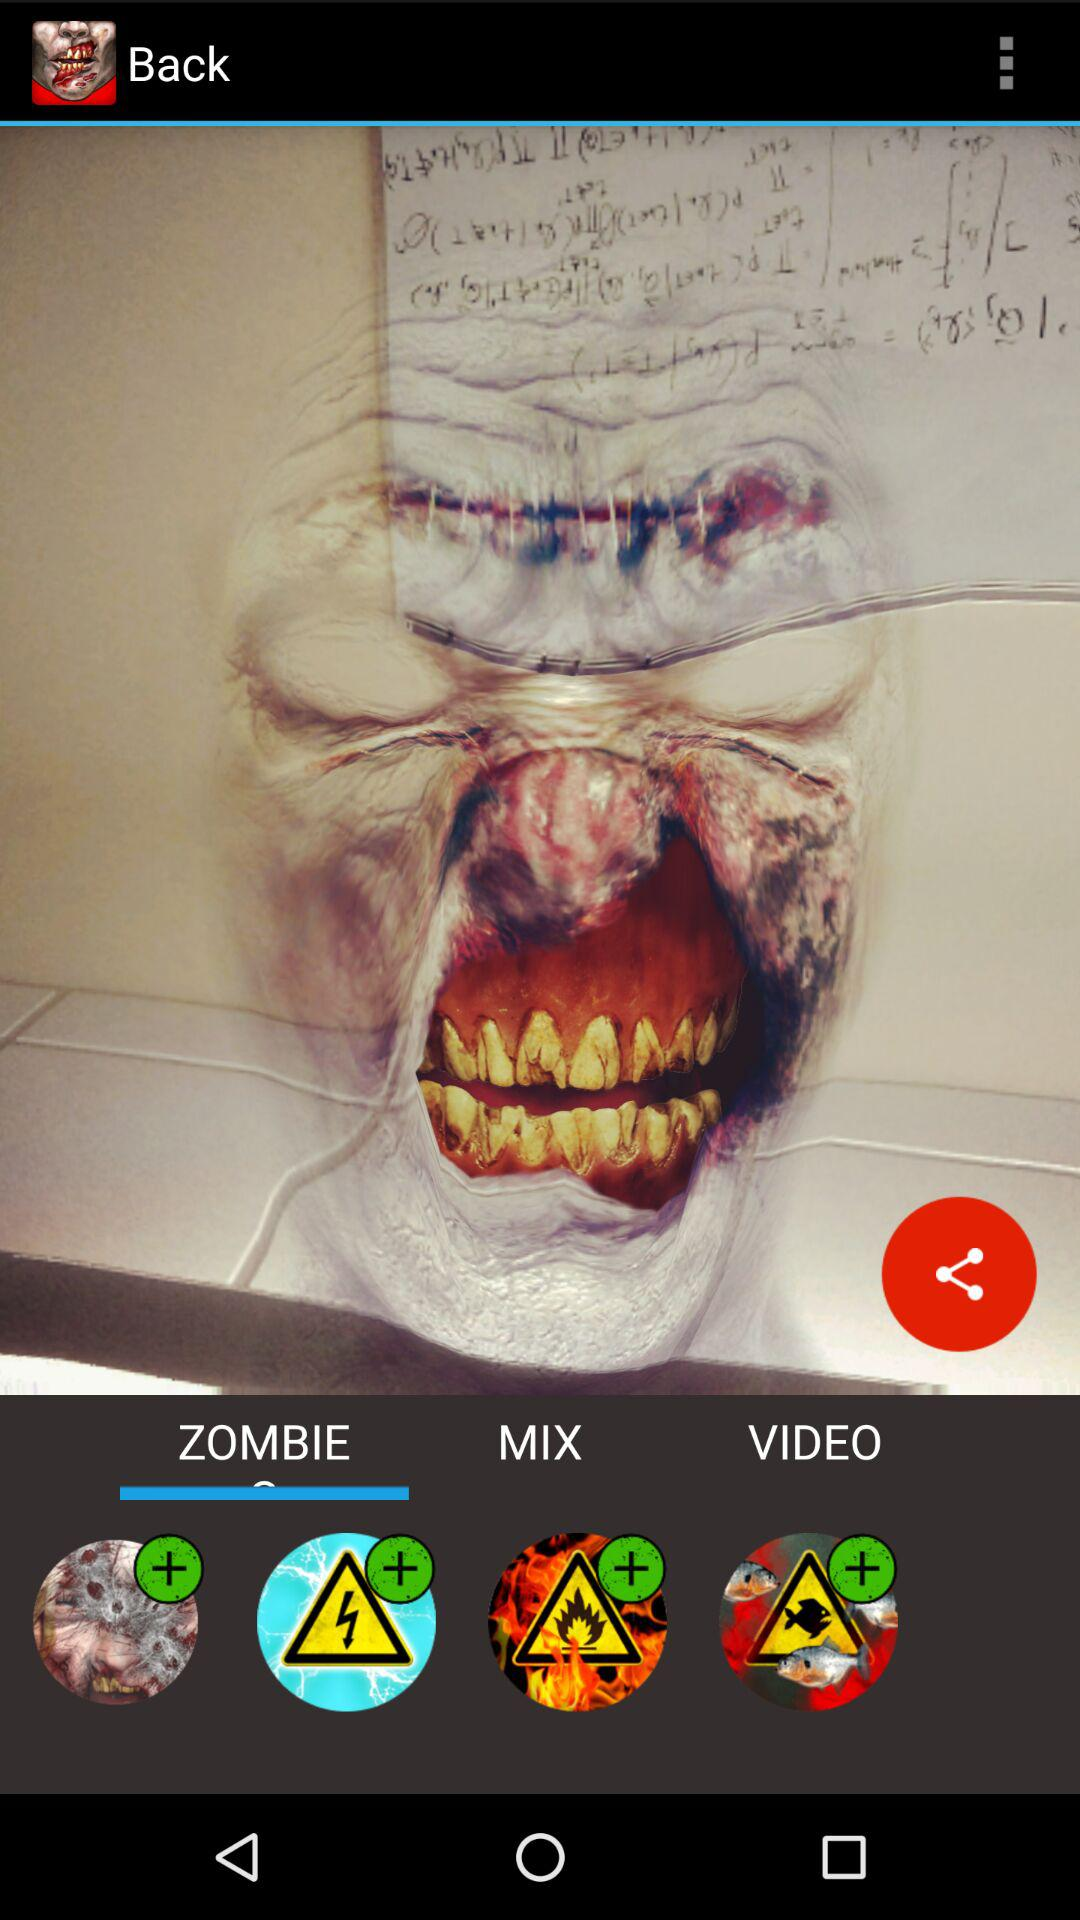Which option is selected? The selected option is "ZOMBIE". 